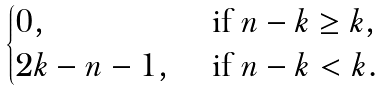<formula> <loc_0><loc_0><loc_500><loc_500>\begin{cases} 0 , & \text { if } n - k \geq k , \\ 2 k - n - 1 , & \text { if } n - k < k . \end{cases}</formula> 